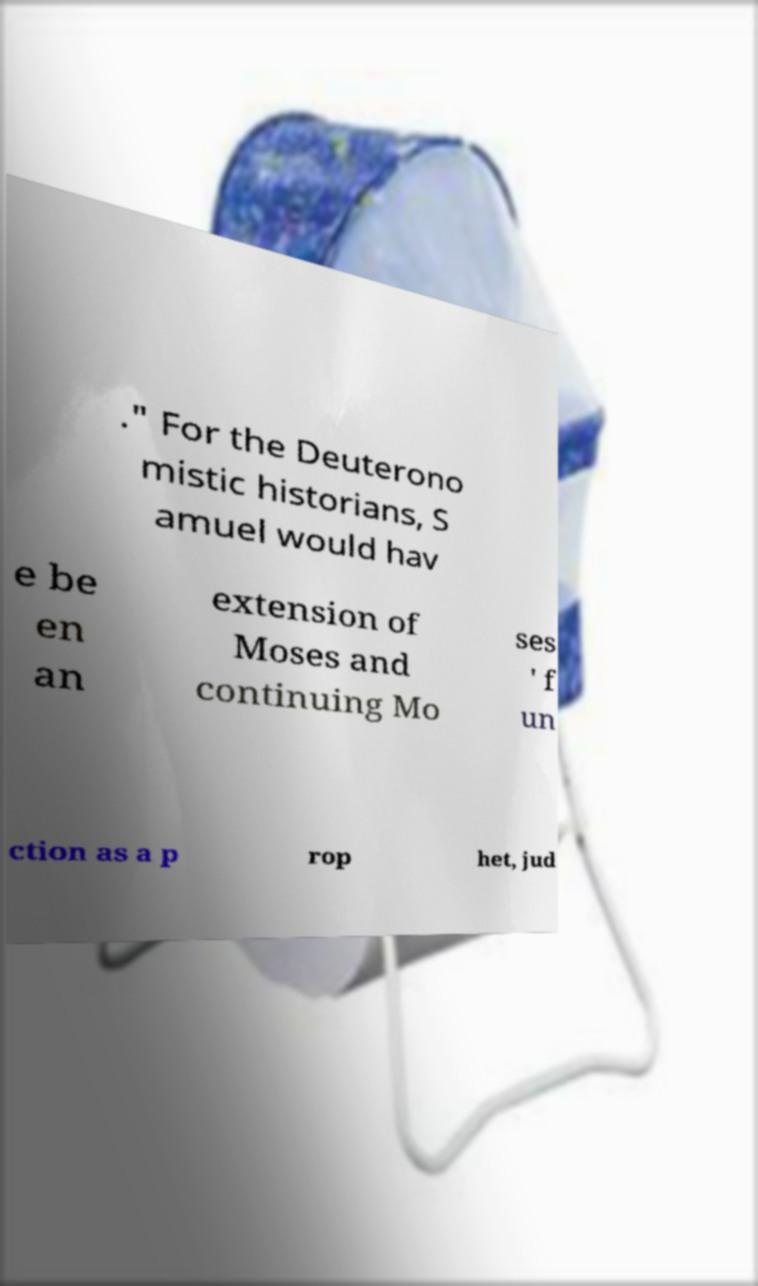What messages or text are displayed in this image? I need them in a readable, typed format. ." For the Deuterono mistic historians, S amuel would hav e be en an extension of Moses and continuing Mo ses ' f un ction as a p rop het, jud 